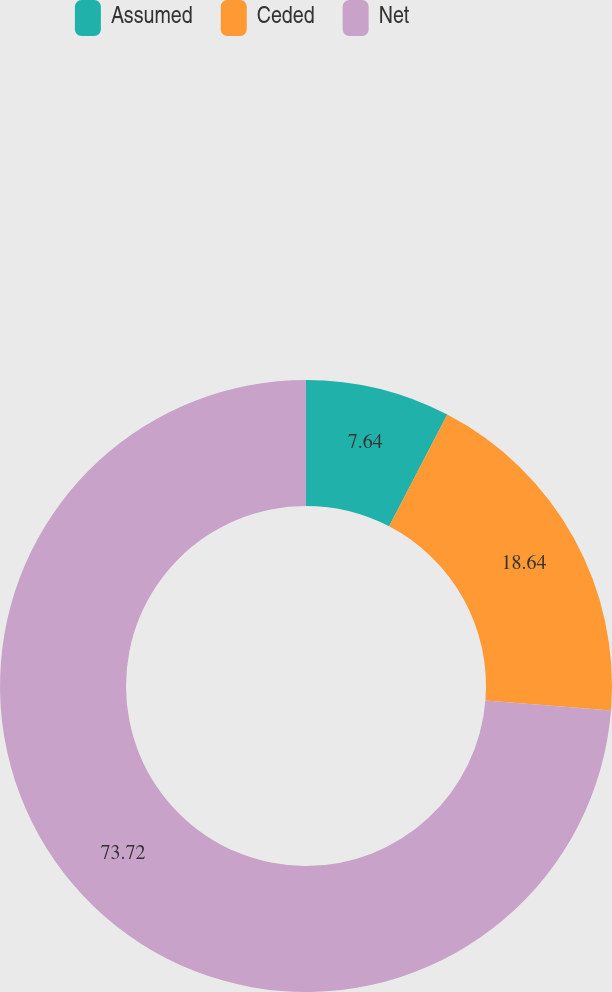Convert chart. <chart><loc_0><loc_0><loc_500><loc_500><pie_chart><fcel>Assumed<fcel>Ceded<fcel>Net<nl><fcel>7.64%<fcel>18.64%<fcel>73.72%<nl></chart> 